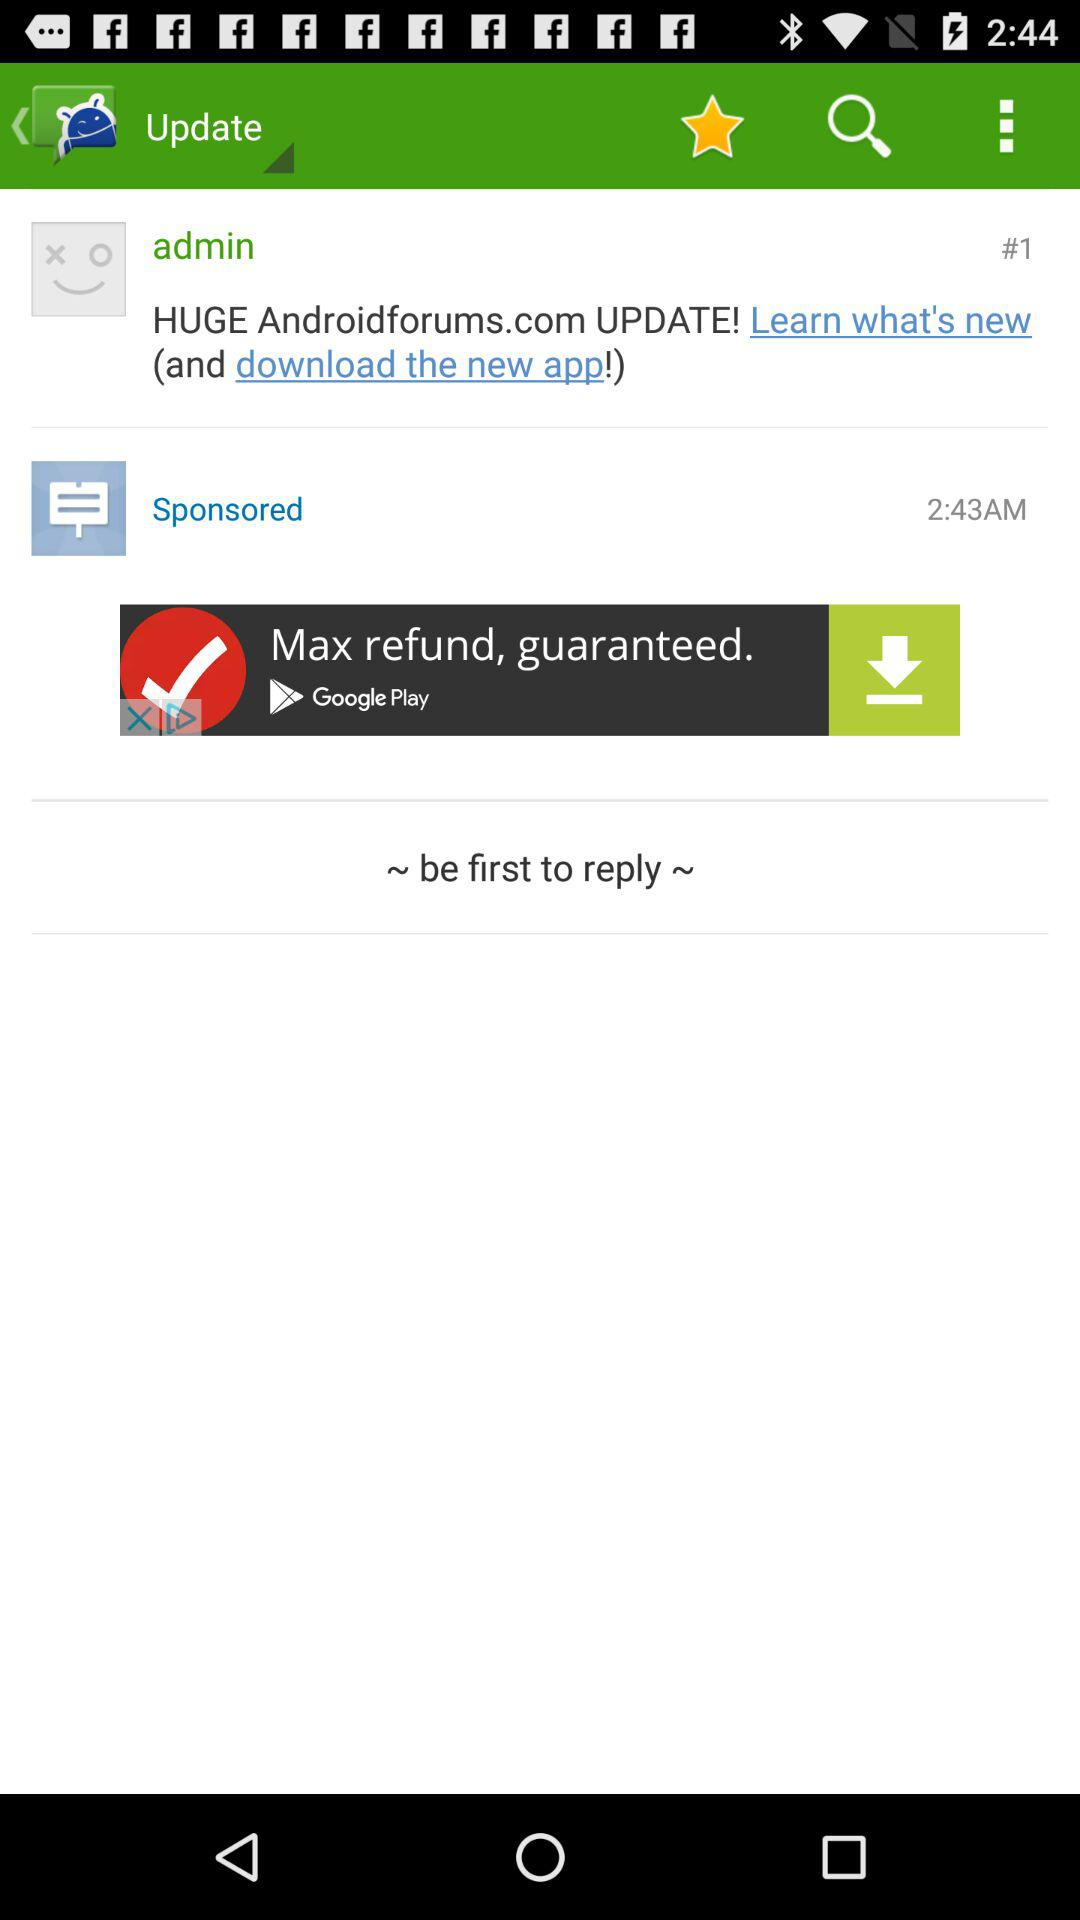What is the mentioned time? The mentioned time is 2:43 AM. 